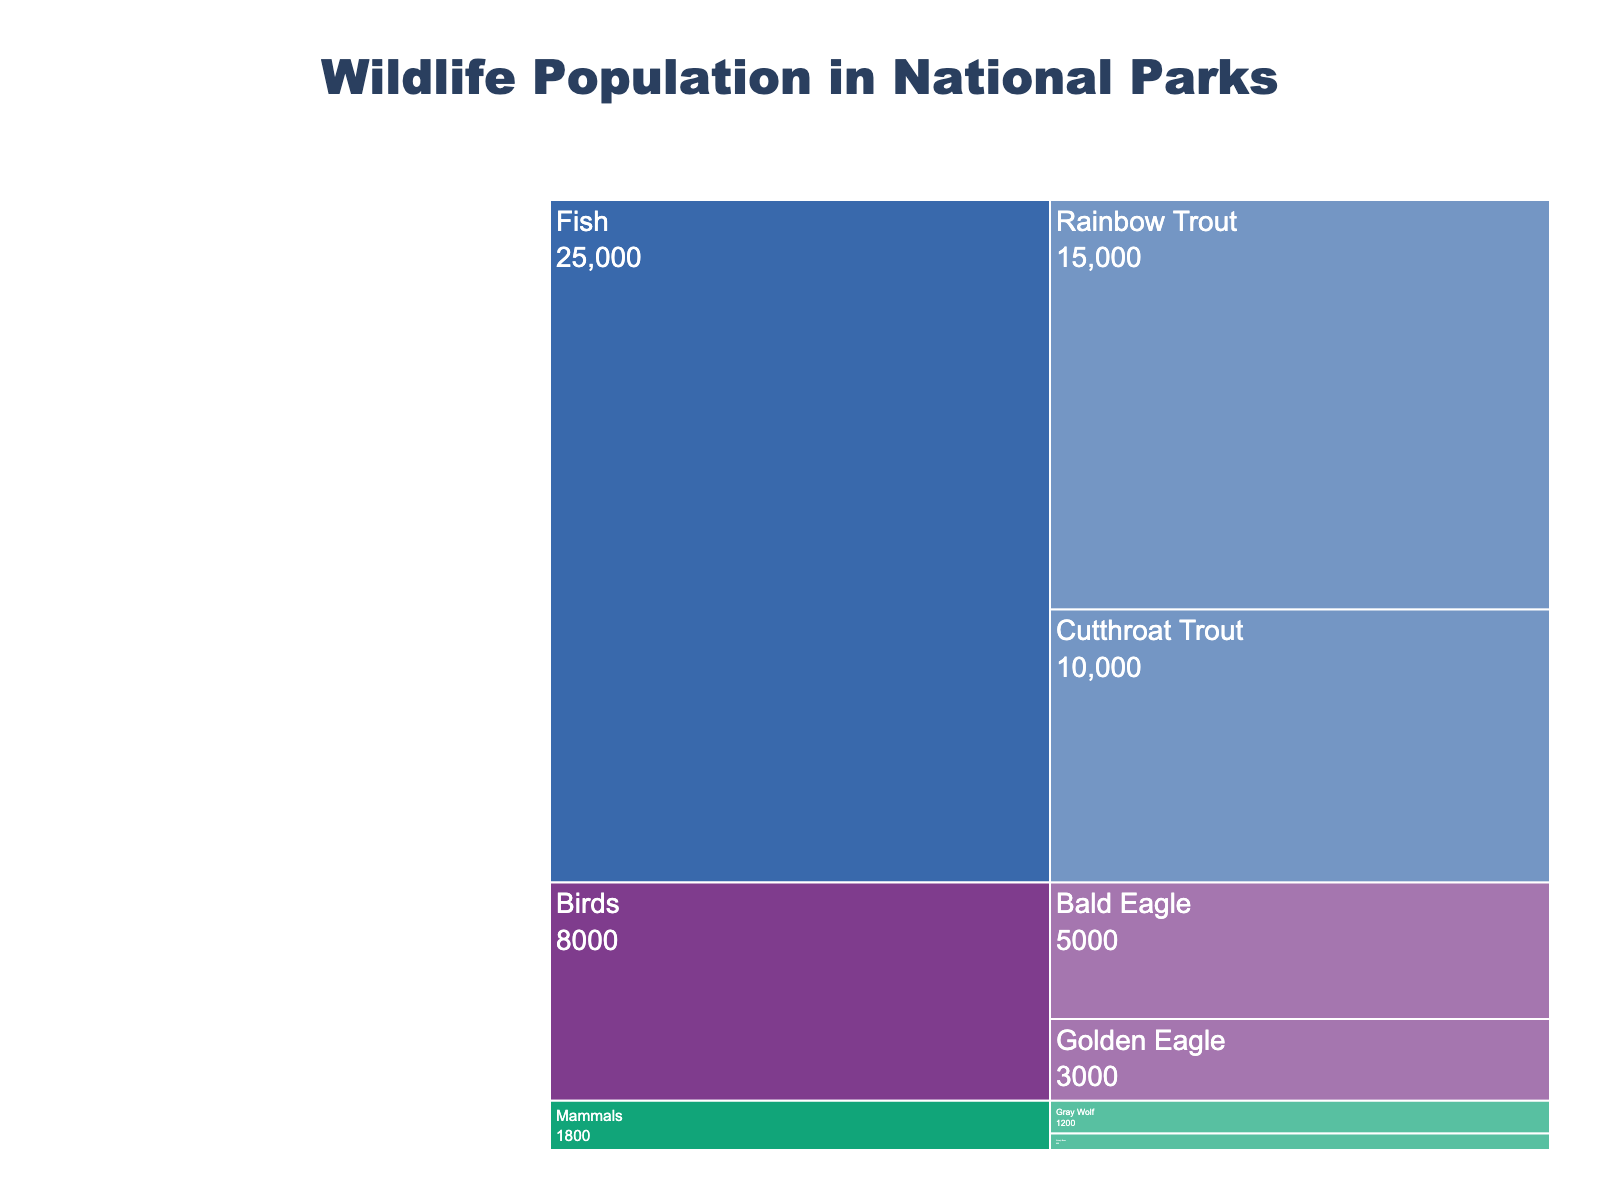what is the title of the chart? The title of the chart is displayed at the top center of the chart. It reads "Wildlife Population in National Parks".
Answer: Wildlife Population in National Parks Which species has the highest population? To find the species with the highest population, we look at the total values per species. It's evident that Fish has the largest blocks within the chart, indicating the highest cumulative population.
Answer: Fish What is the population of Golden Eagles? The population of each subspecies is labeled on the icicle chart. The label for Golden Eagles shows 3000.
Answer: 3000 What is the total population of all Mammals? Calculate the total population by adding the values for each subspecies under Mammals: Gray Wolf: 1200, Grizzly Bear: 600. Summing these gives 1200 + 600 = 1800.
Answer: 1800 Compare the population of Rainbow Trout and Cutthroat Trout. Which one is larger? Look at the values associated with Rainbow Trout and Cutthroat Trout. Rainbow Trout has 15,000 while Cutthroat Trout has 10,000. Rainbow Trout has a larger population.
Answer: Rainbow Trout Which Bird species has a higher population, Bald Eagle or Golden Eagle? Check the values for Bald Eagle and Golden Eagle. Bald Eagle has a population of 5000, while Golden Eagle has a population of 3000. Bald Eagle has a higher population.
Answer: Bald Eagle What species is represented by the largest individual subspecies population? Identify the highest population among the subspecies. The highest value is with Rainbow Trout at 15,000. Therefore, Fish represents the largest individual subspecies population.
Answer: Fish What is the average population of the two Eagle subspecies? To find the average, sum the populations of Bald and Golden Eagle and divide by the number of subspecies (2). That is (5000 + 3000) / 2 = 4000.
Answer: 4000 How does the population of Grizzly Bears compare to Gray Wolves? Compare the values of Grizzly Bears and Gray Wolves. Grizzly Bears have a population of 600, and Gray Wolves have 1200. Gray Wolves have a higher population.
Answer: Gray Wolves Which fish subspecies has the smaller population? Compare the values of Rainbow Trout and Cutthroat Trout. Rainbow Trout has 15,000 while Cutthroat Trout has 10,000. Cutthroat Trout has the smaller population.
Answer: Cutthroat Trout 